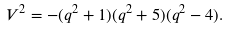Convert formula to latex. <formula><loc_0><loc_0><loc_500><loc_500>V ^ { 2 } = - ( q ^ { 2 } + 1 ) ( q ^ { 2 } + 5 ) ( q ^ { 2 } - 4 ) .</formula> 